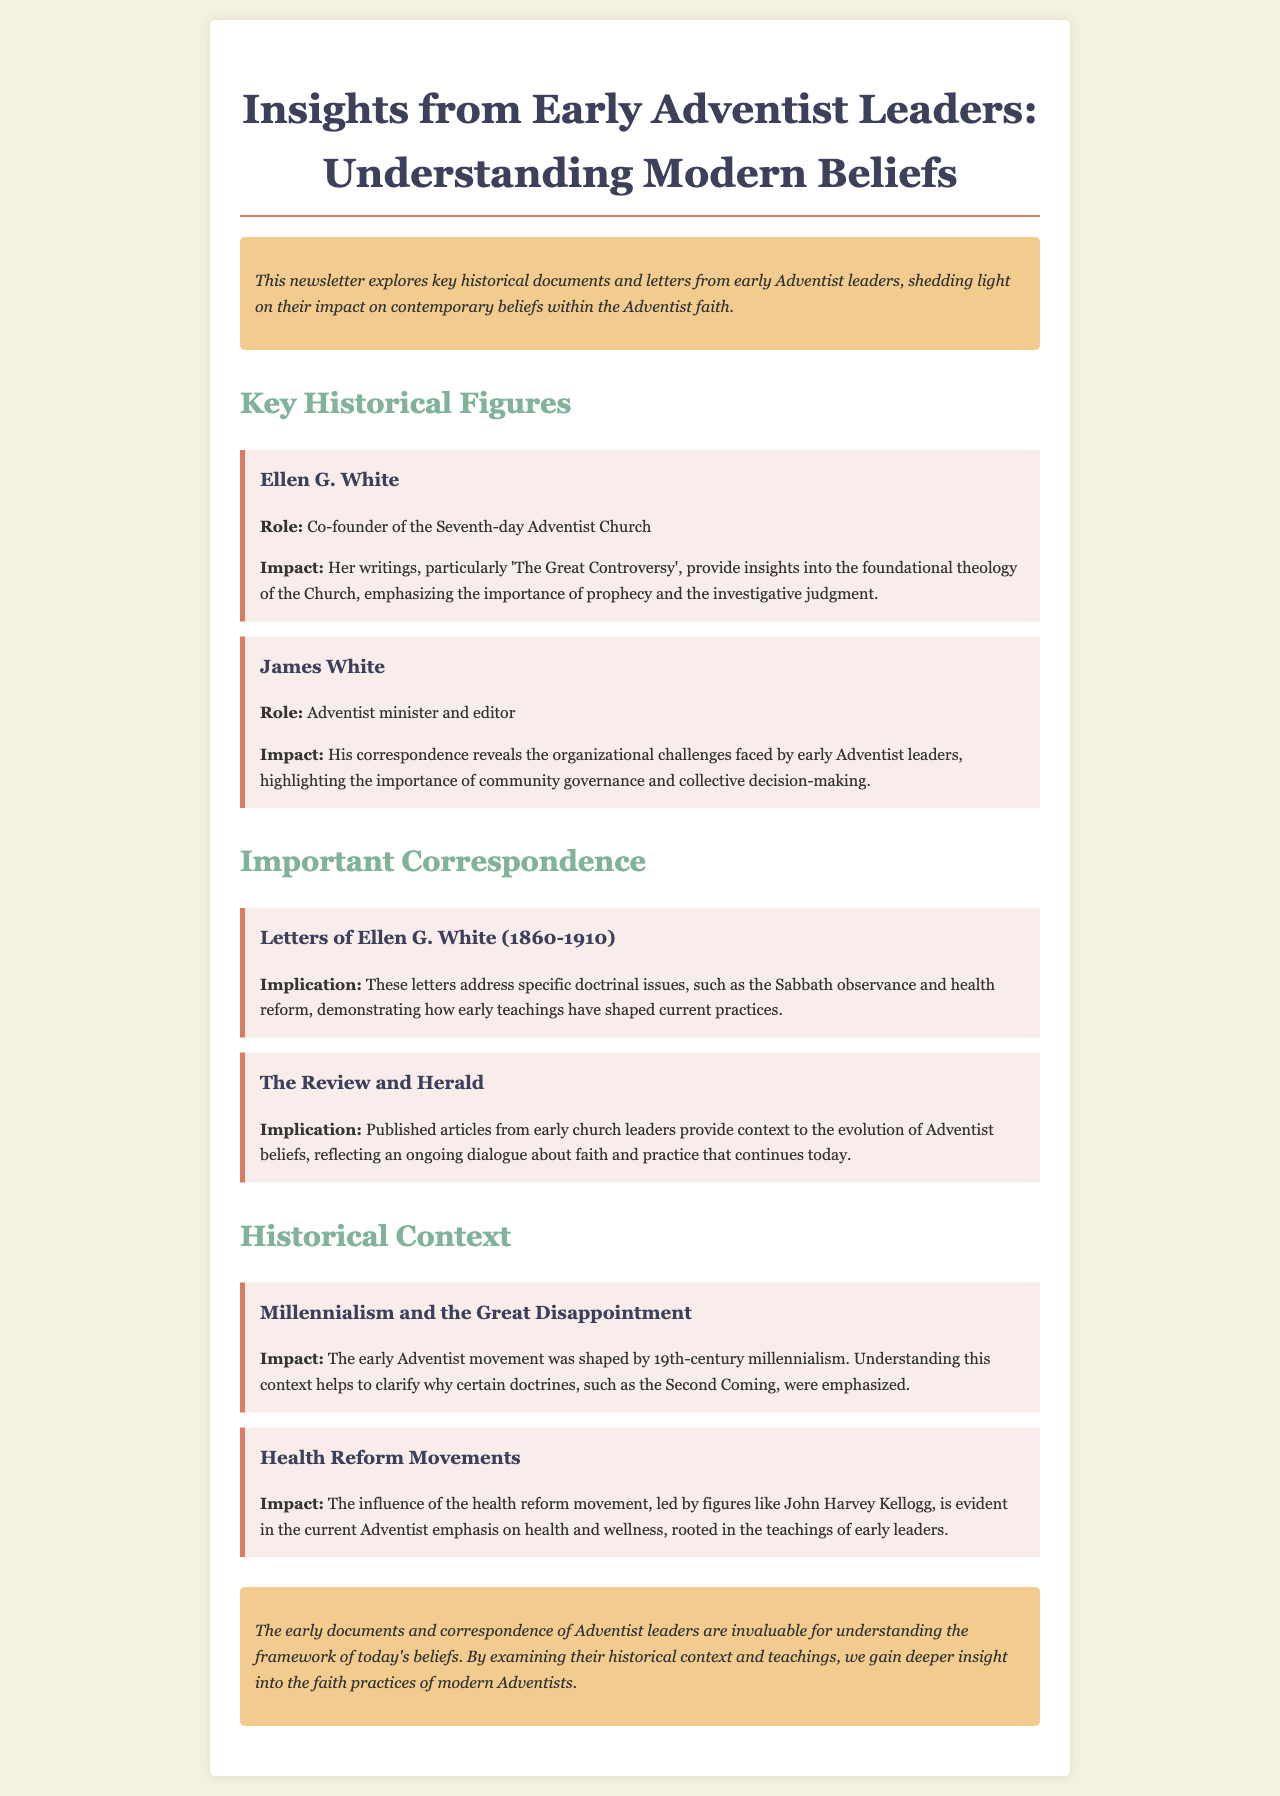What is the title of the newsletter? The title of the newsletter is mentioned at the top of the document.
Answer: Insights from Early Adventist Leaders: Understanding Modern Beliefs Who is the co-founder of the Seventh-day Adventist Church? The document states that Ellen G. White is a co-founder of the Seventh-day Adventist Church.
Answer: Ellen G. White What significant work did Ellen G. White write? The newsletter highlights 'The Great Controversy' as a significant work by Ellen G. White.
Answer: The Great Controversy What year range do Ellen G. White's letters cover? The document specifies that her letters span from 1860 to 1910.
Answer: 1860-1910 Which publication provided context to the evolution of Adventist beliefs? The document mentions The Review and Herald as a key publication for understanding Adventist beliefs.
Answer: The Review and Herald What was a major sociopolitical influence on early Adventist doctrine? The newsletter discusses millennialism as a significant influence on early Adventist doctrine.
Answer: Millennialism Who led the health reform movement associated with early Adventists? The document notes that John Harvey Kellogg was a key figure in the health reform movement.
Answer: John Harvey Kellogg What kind of correspondence is highlighted in the newsletter? The newsletter highlights letters from early Adventist leaders as a type of correspondence.
Answer: Letters What impact did the health reform movement have on modern Adventist beliefs? The document indicates that the health reform movement influenced the current Adventist emphasis on health and wellness.
Answer: Health and wellness 